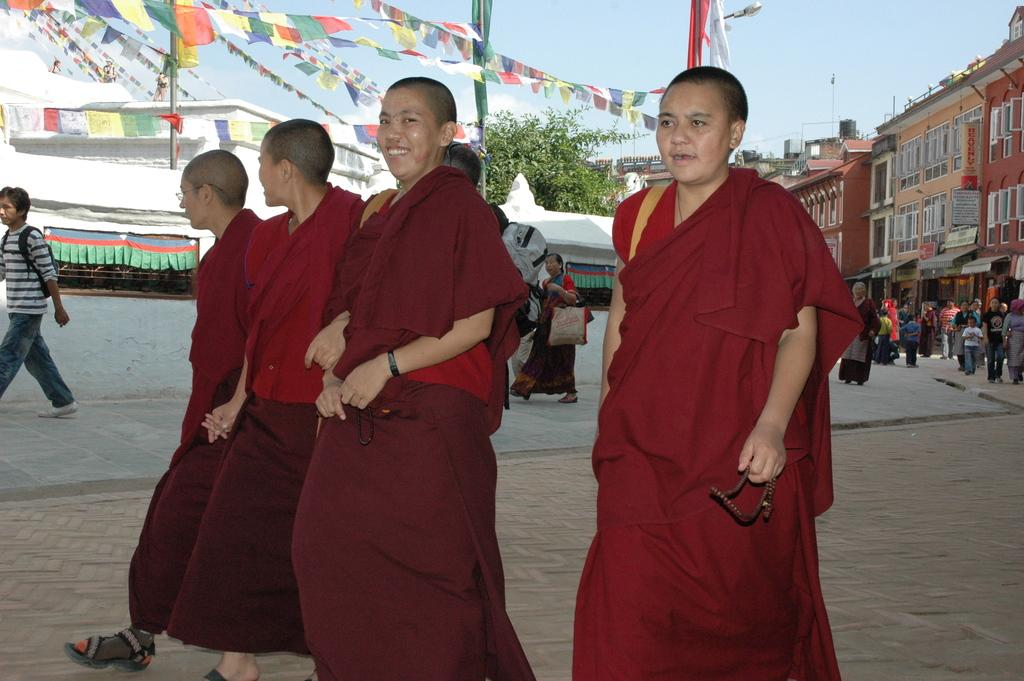What are the people in the front of the image doing? The persons standing and smiling in the front of the image are smiling. What can be seen in the background of the image? In the background of the image, there are tents, buildings, flags, poles, and a tree. Are there any other people visible in the image? Yes, there are persons in the background of the image. What type of pump is being used to inflate the tents in the image? There is no pump visible in the image, and the tents do not appear to be inflated. What kind of apparatus is being used by the persons in the background to communicate with each other? There is no apparatus visible in the image that would suggest communication between the persons in the background. 